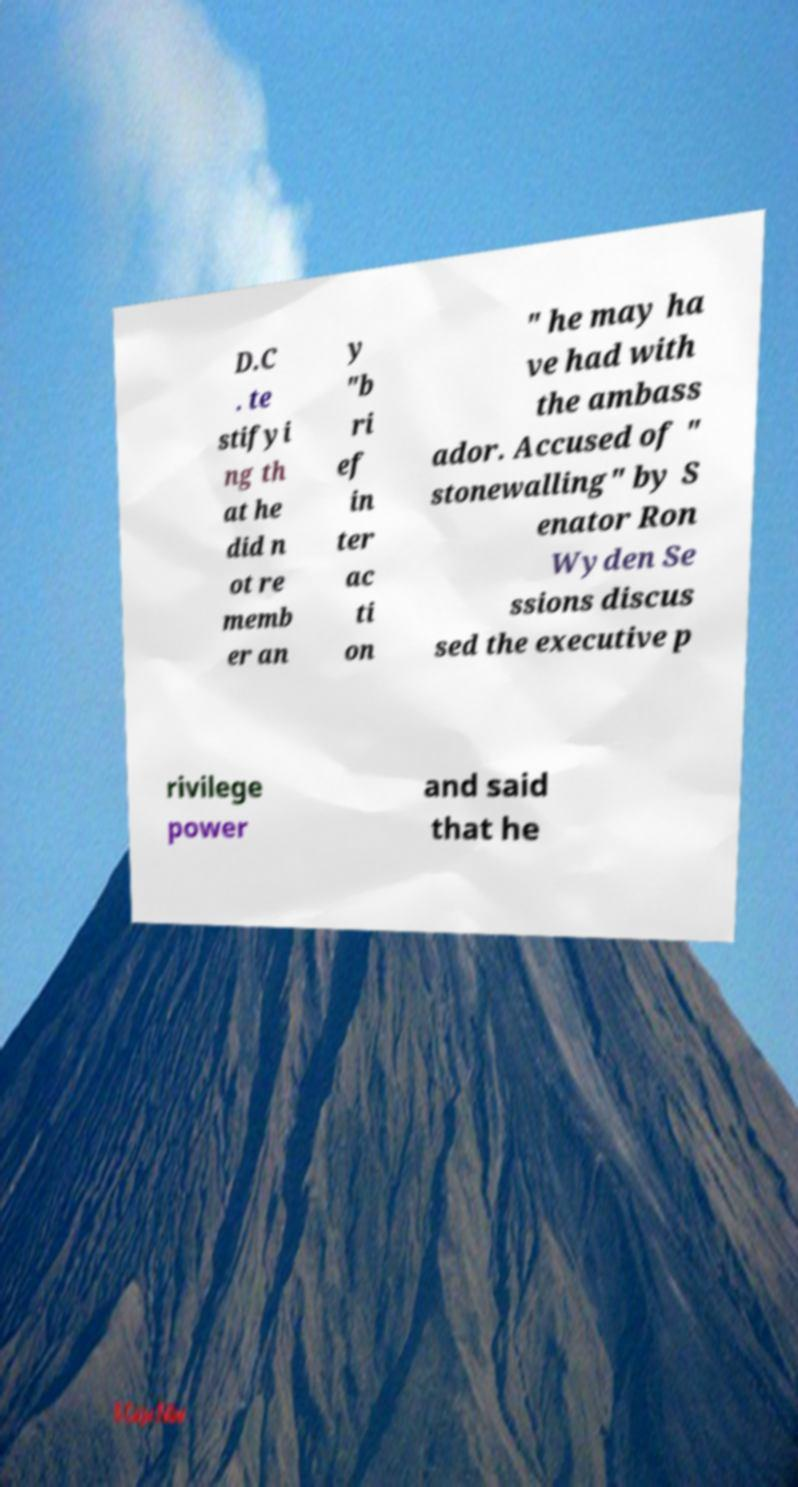Could you assist in decoding the text presented in this image and type it out clearly? D.C . te stifyi ng th at he did n ot re memb er an y "b ri ef in ter ac ti on " he may ha ve had with the ambass ador. Accused of " stonewalling" by S enator Ron Wyden Se ssions discus sed the executive p rivilege power and said that he 